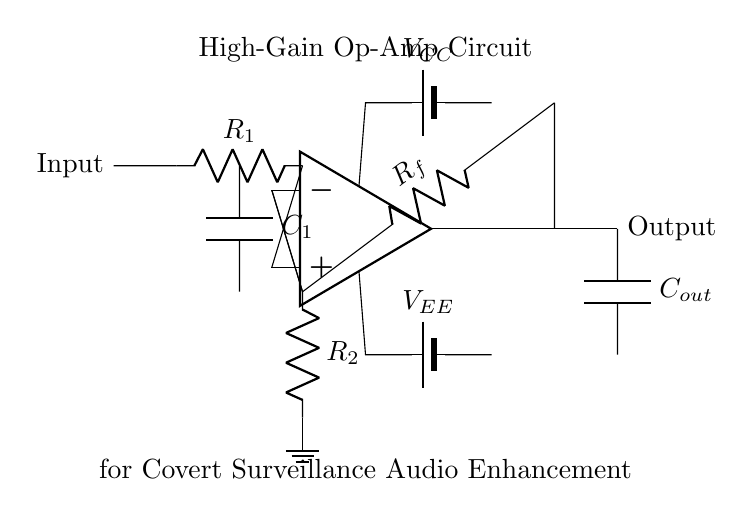What is the input component in this circuit? The input component, identified in the diagram, is a resistor labeled R1, which receives the weak audio signal to be amplified.
Answer: R1 What are the supply voltages in this circuit? The circuit features two power supplies, indicated as VCC and VEE, which provide the necessary biasing for the operational amplifier's operation.
Answer: VCC, VEE What is the function of the feedback resistor? The feedback resistor, labeled Rf, establishes the gain of the operational amplifier by returning a portion of the output signal back to the inverting input, determining the overall amplification factor.
Answer: Gain adjustment Which components are used for noise reduction? The circuit includes capacitors labeled C1 and Cout, which are used to filter noise and stabilize the signal quality to prevent unwanted interference in the output audio signal.
Answer: C1, Cout What type of operational amplifier configuration is shown? The circuit is an inverting amplifier configuration, as indicated by the arrangement of the feedback and input resistances connected to the operational amplifier inputs.
Answer: Inverting amplifier What role does the capacitor Cout serve in the circuit? The capacitor Cout, connected to the output, helps in blocking any DC component in the output signal, allowing only the amplified AC audio signal to pass to the subsequent stage or device.
Answer: DC blocking 